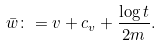<formula> <loc_0><loc_0><loc_500><loc_500>\bar { w } \colon = v + c _ { v } + \frac { \log t } { 2 m } .</formula> 